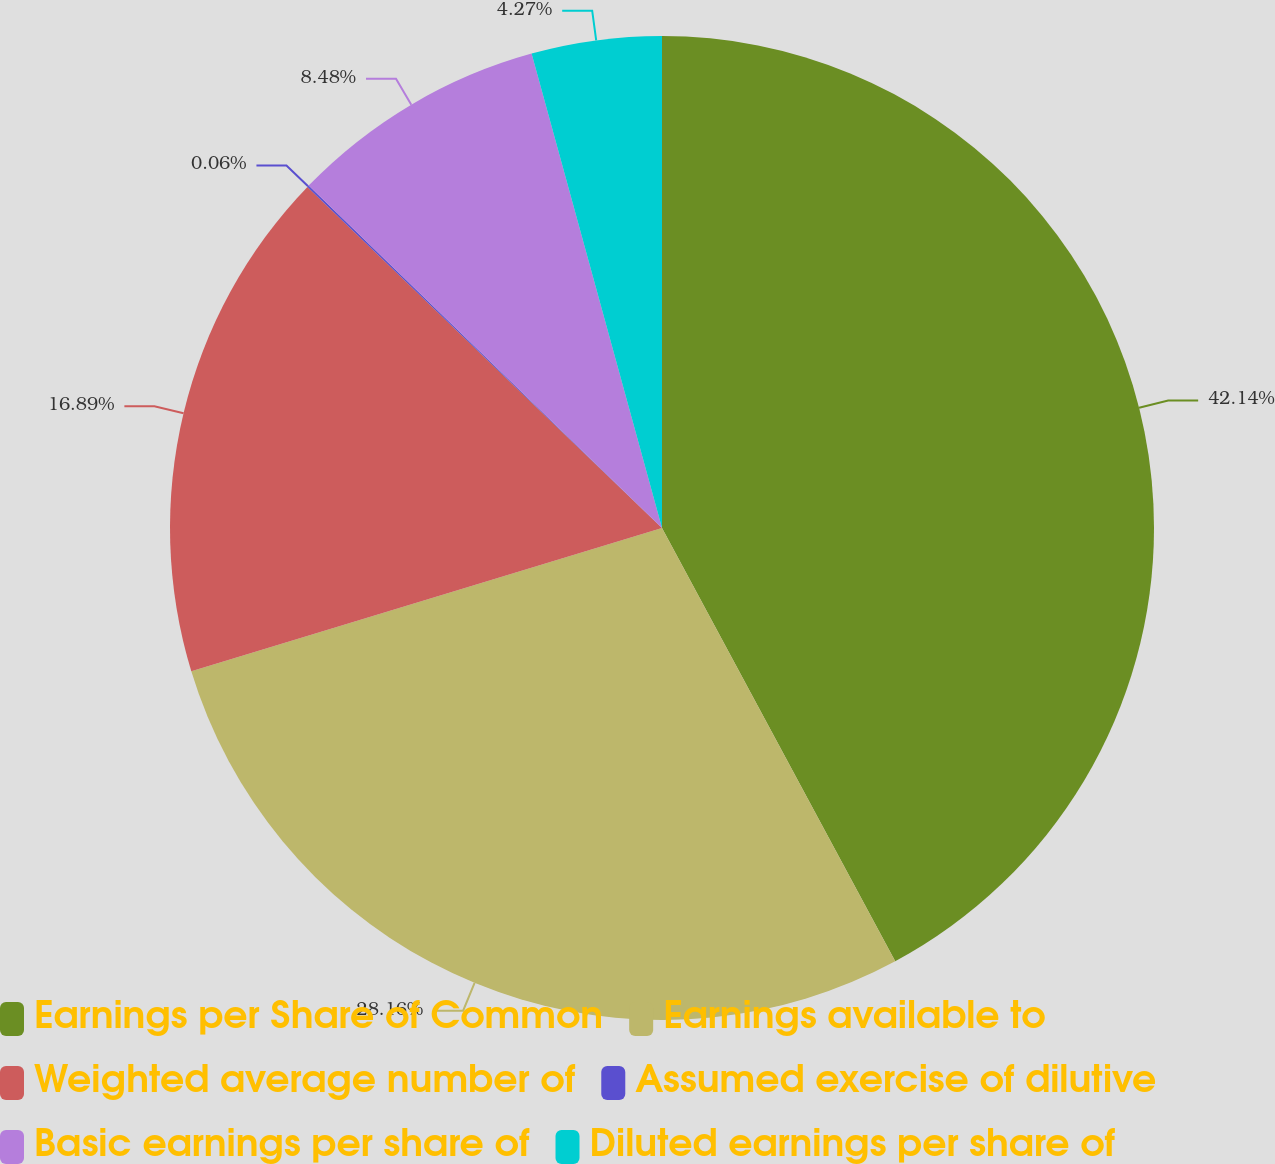Convert chart to OTSL. <chart><loc_0><loc_0><loc_500><loc_500><pie_chart><fcel>Earnings per Share of Common<fcel>Earnings available to<fcel>Weighted average number of<fcel>Assumed exercise of dilutive<fcel>Basic earnings per share of<fcel>Diluted earnings per share of<nl><fcel>42.14%<fcel>28.16%<fcel>16.89%<fcel>0.06%<fcel>8.48%<fcel>4.27%<nl></chart> 